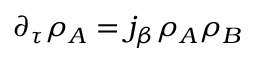<formula> <loc_0><loc_0><loc_500><loc_500>\partial _ { \tau } \rho _ { A } = j _ { \beta } \rho _ { A } \rho _ { B }</formula> 